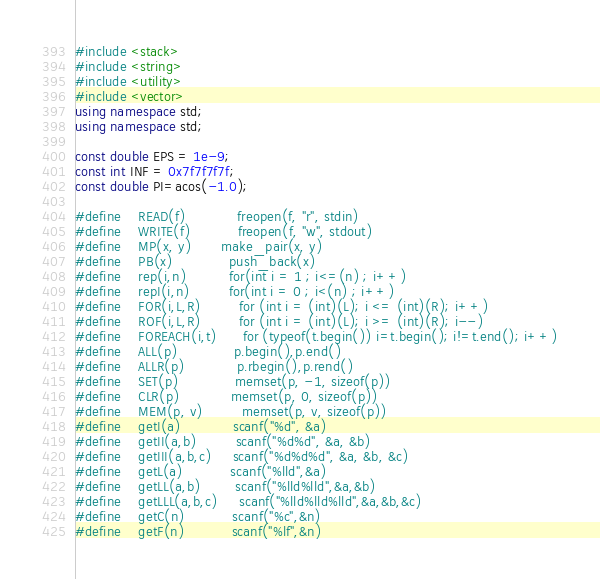Convert code to text. <code><loc_0><loc_0><loc_500><loc_500><_C++_>#include <stack>
#include <string>
#include <utility>
#include <vector>
using namespace std;
using namespace std;

const double EPS = 1e-9;
const int INF = 0x7f7f7f7f;
const double PI=acos(-1.0);

#define    READ(f) 	         freopen(f, "r", stdin)
#define    WRITE(f)   	     freopen(f, "w", stdout)
#define    MP(x, y) 	     make_pair(x, y)
#define    PB(x)             push_back(x)
#define    rep(i,n)          for(int i = 1 ; i<=(n) ; i++)
#define    repI(i,n)         for(int i = 0 ; i<(n) ; i++)
#define    FOR(i,L,R) 	     for (int i = (int)(L); i <= (int)(R); i++)
#define    ROF(i,L,R) 	     for (int i = (int)(L); i >= (int)(R); i--)
#define    FOREACH(i,t)      for (typeof(t.begin()) i=t.begin(); i!=t.end(); i++)
#define    ALL(p) 	         p.begin(),p.end()
#define    ALLR(p) 	         p.rbegin(),p.rend()
#define    SET(p) 	         memset(p, -1, sizeof(p))
#define    CLR(p)            memset(p, 0, sizeof(p))
#define    MEM(p, v)         memset(p, v, sizeof(p))
#define    getI(a) 	         scanf("%d", &a)
#define    getII(a,b) 	     scanf("%d%d", &a, &b)
#define    getIII(a,b,c)     scanf("%d%d%d", &a, &b, &c)
#define    getL(a)           scanf("%lld",&a)
#define    getLL(a,b)        scanf("%lld%lld",&a,&b)
#define    getLLL(a,b,c)     scanf("%lld%lld%lld",&a,&b,&c)
#define    getC(n)           scanf("%c",&n)
#define    getF(n)           scanf("%lf",&n)</code> 